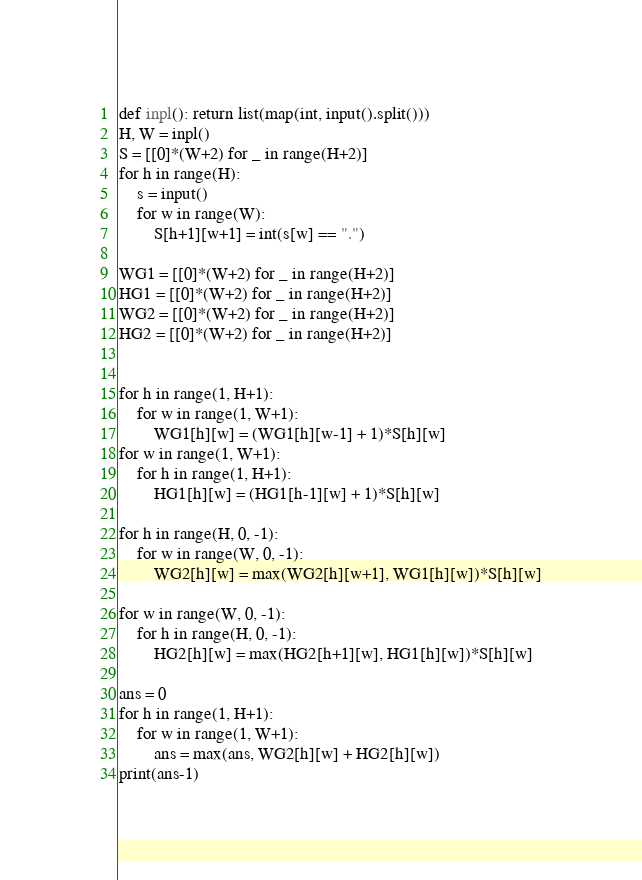Convert code to text. <code><loc_0><loc_0><loc_500><loc_500><_Python_>def inpl(): return list(map(int, input().split()))
H, W = inpl()
S = [[0]*(W+2) for _ in range(H+2)]
for h in range(H):
    s = input()
    for w in range(W):
        S[h+1][w+1] = int(s[w] == ".")

WG1 = [[0]*(W+2) for _ in range(H+2)]
HG1 = [[0]*(W+2) for _ in range(H+2)]
WG2 = [[0]*(W+2) for _ in range(H+2)]
HG2 = [[0]*(W+2) for _ in range(H+2)]


for h in range(1, H+1):
    for w in range(1, W+1):
        WG1[h][w] = (WG1[h][w-1] + 1)*S[h][w]
for w in range(1, W+1):
    for h in range(1, H+1):
        HG1[h][w] = (HG1[h-1][w] + 1)*S[h][w]

for h in range(H, 0, -1):
    for w in range(W, 0, -1):
        WG2[h][w] = max(WG2[h][w+1], WG1[h][w])*S[h][w]

for w in range(W, 0, -1):
    for h in range(H, 0, -1):
        HG2[h][w] = max(HG2[h+1][w], HG1[h][w])*S[h][w]

ans = 0
for h in range(1, H+1):
    for w in range(1, W+1):
        ans = max(ans, WG2[h][w] + HG2[h][w])
print(ans-1)</code> 